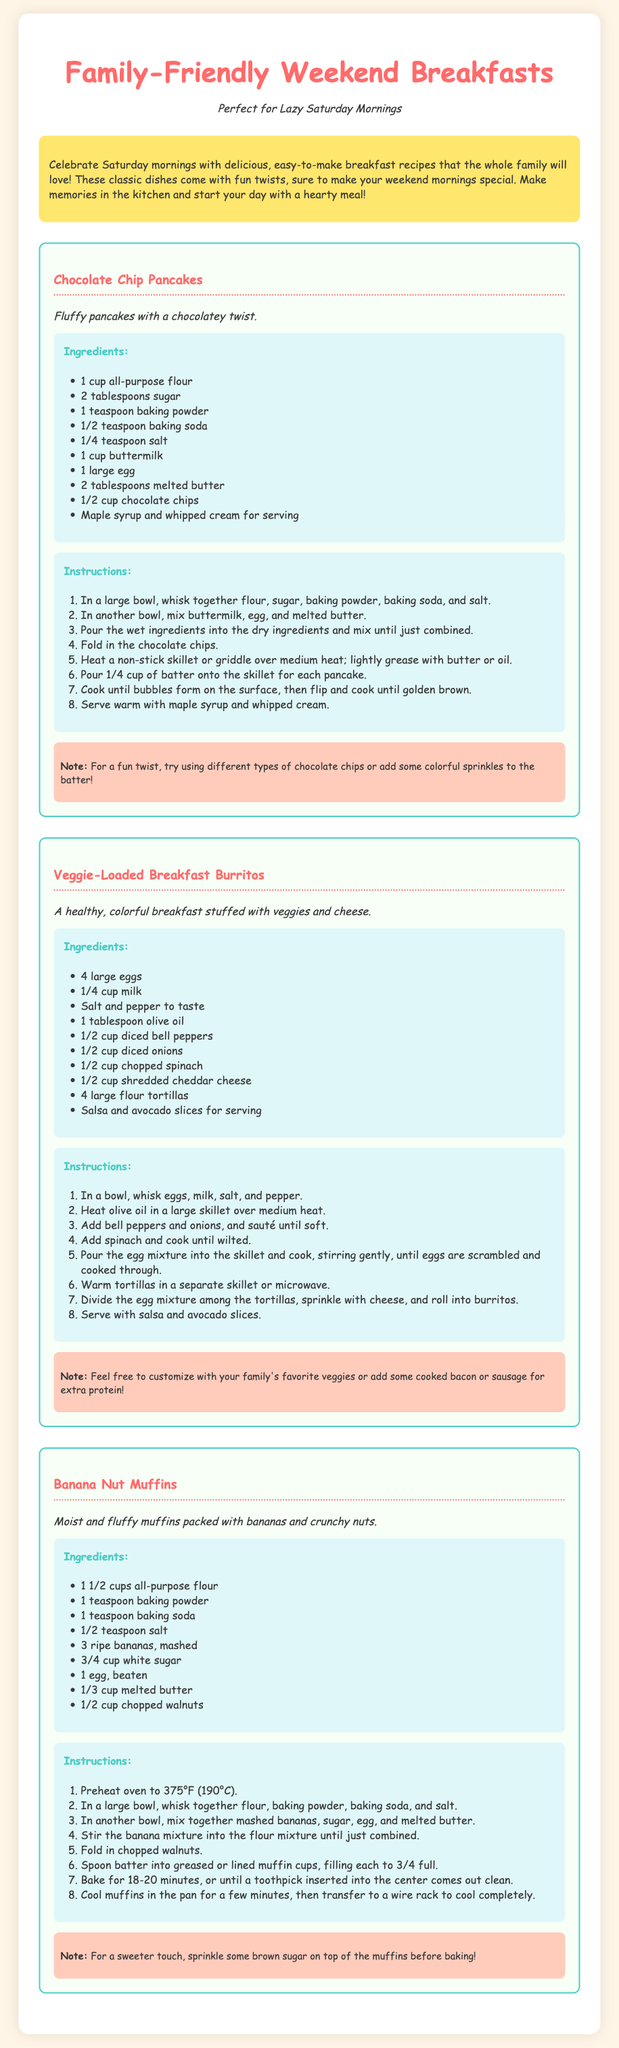What is the title of the document? The title of the document is found in the header section and describes the content presented.
Answer: Family-Friendly Weekend Breakfasts How many recipes are included? There are three distinct breakfast recipes featured within the document, each contained in its own section.
Answer: 3 What type of pancakes are featured in the first recipe? The first recipe specifically mentions the type of pancakes, which adds a unique element to this classic dish.
Answer: Chocolate Chip Pancakes What is the total number of eggs used in the Veggie-Loaded Breakfast Burritos recipe? The recipe indicates the quantity of eggs required, which is an important part of the ingredient list for this dish.
Answer: 4 Which ingredient is recommended for serving with Banana Nut Muffins? The document provides suggestions for enhancing the presentation or flavor of the muffins, making this a sought-after detail.
Answer: Brown sugar What cooking temperature is suggested for baking the Banana Nut Muffins? The cooking temperature is crucial for successfully preparing the muffins, as stated in the instructions section of the recipe.
Answer: 375°F (190°C) What note is provided with the Chocolate Chip Pancakes recipe? A specific note describes an optional fun twist to enhance the basic recipe, contributing to the user’s customization ability.
Answer: Different types of chocolate chips or colorful sprinkles In what format is the ingredient list presented? The ingredient list format is generally consistent across recipes, aiding in clarity and usability for the reader.
Answer: Unordered list 